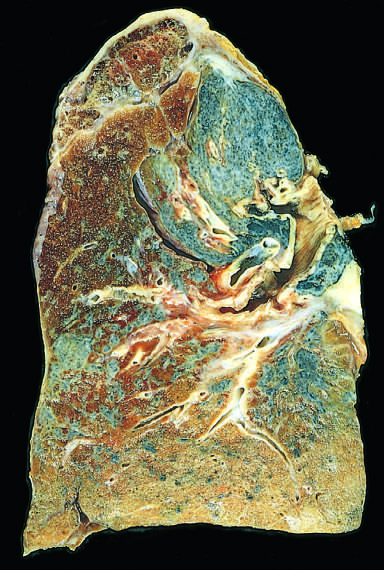what has scarring contracted into a small dark mass?
Answer the question using a single word or phrase. The upper lobe 